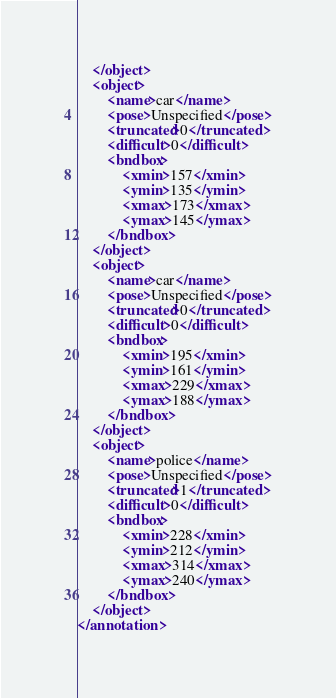<code> <loc_0><loc_0><loc_500><loc_500><_XML_>	</object>
	<object>
		<name>car</name>
		<pose>Unspecified</pose>
		<truncated>0</truncated>
		<difficult>0</difficult>
		<bndbox>
			<xmin>157</xmin>
			<ymin>135</ymin>
			<xmax>173</xmax>
			<ymax>145</ymax>
		</bndbox>
	</object>
	<object>
		<name>car</name>
		<pose>Unspecified</pose>
		<truncated>0</truncated>
		<difficult>0</difficult>
		<bndbox>
			<xmin>195</xmin>
			<ymin>161</ymin>
			<xmax>229</xmax>
			<ymax>188</ymax>
		</bndbox>
	</object>
	<object>
		<name>police</name>
		<pose>Unspecified</pose>
		<truncated>1</truncated>
		<difficult>0</difficult>
		<bndbox>
			<xmin>228</xmin>
			<ymin>212</ymin>
			<xmax>314</xmax>
			<ymax>240</ymax>
		</bndbox>
	</object>
</annotation>
</code> 